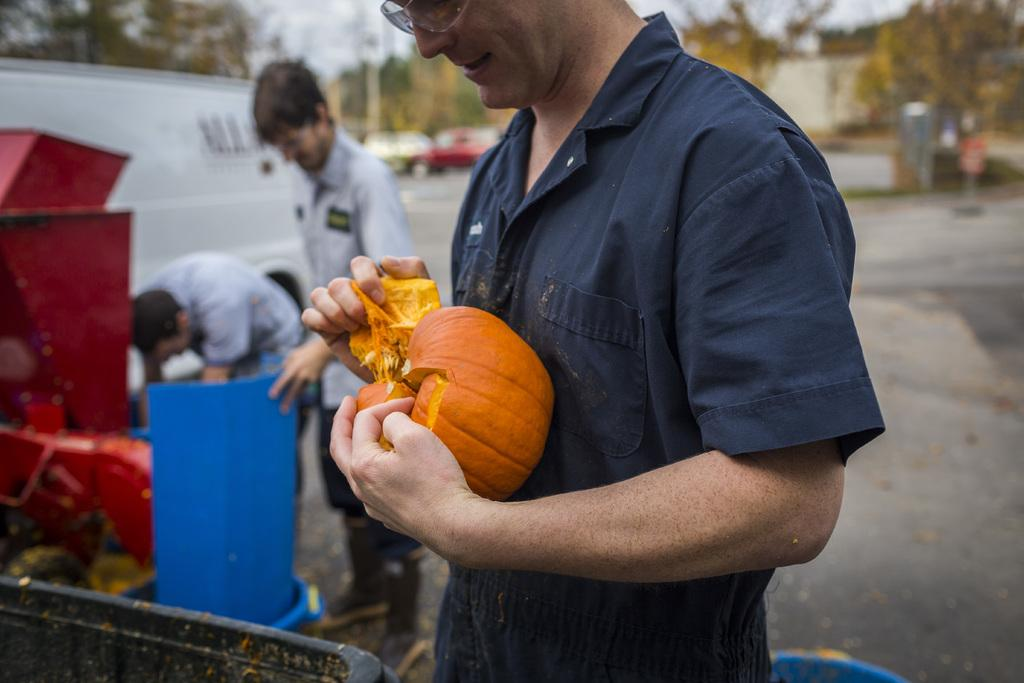What is happening in the middle of the image? There are people standing in the middle of the image. What are the people holding in their hands? The people are holding something in their hands. What can be seen in the background of the image? Trees, vehicles, and poles are visible in the background. How would you describe the background of the image? The background of the image is blurred. Can you tell me how many worms are crawling on the people's hands in the image? There are no worms present in the image; the people are holding something else in their hands. What verse is being recited by the people in the image? There is no indication in the image that the people are reciting a verse or any form of spoken word. 